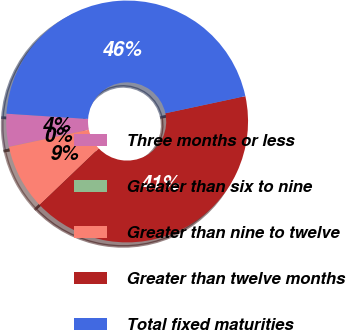Convert chart to OTSL. <chart><loc_0><loc_0><loc_500><loc_500><pie_chart><fcel>Three months or less<fcel>Greater than six to nine<fcel>Greater than nine to twelve<fcel>Greater than twelve months<fcel>Total fixed maturities<nl><fcel>4.39%<fcel>0.01%<fcel>8.76%<fcel>41.23%<fcel>45.61%<nl></chart> 